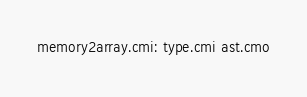<code> <loc_0><loc_0><loc_500><loc_500><_D_>memory2array.cmi: type.cmi ast.cmo
</code> 